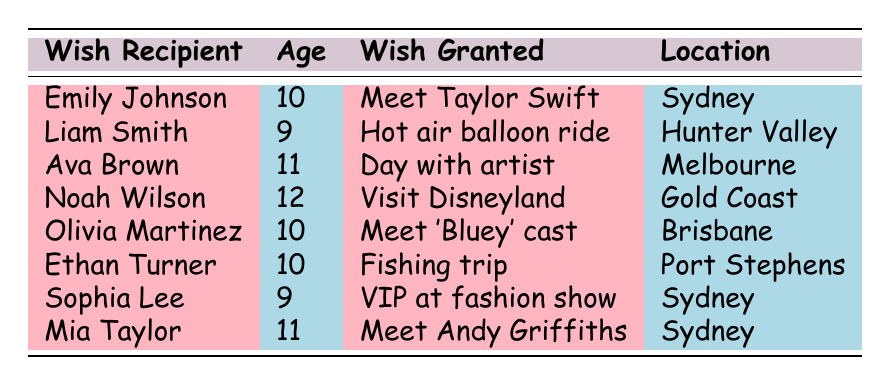What is the wish granted to Emily Johnson? According to the table, Emily Johnson's wish granted was to meet her favorite singer, Taylor Swift.
Answer: Meet Taylor Swift How many wish recipients are 10 years old? The table lists three recipients who are 10 years old: Emily Johnson, Olivia Martinez, and Ethan Turner.
Answer: 3 Which location had the most wishes granted? The table does not list any repeated locations; each location appears only once. Thus, no location has more than one wish granted.
Answer: No location has multiple wishes What type of wish did Liam Smith receive? Referring to the table, Liam Smith received an "Adventure" type wish to go on a hot air balloon ride.
Answer: Adventure Is Mia Taylor's wish granted related to a book or a TV show? The table states that Mia Taylor's wish was to meet her favorite author, Andy Griffiths, which relates to books, not a TV show.
Answer: No How many wishes were granted in Sydney? The table shows that three wishes were granted in Sydney: Emily Johnson, Sophia Lee, and Mia Taylor.
Answer: 3 Which wish recipients are older than 10 years? From the table, the recipients older than 10 years old are Ava Brown (11) and Noah Wilson (12).
Answer: 2 What is the total number of wish recipients listed? The table lists a total of eight wish recipients, counting each entry.
Answer: 8 Which wish granted was the latest in the year? The table shows that the latest wish granted was to Olivia Martinez on August 5, 2023.
Answer: August 5, 2023 Are there more adventure type wishes or experience type wishes granted? By looking at the table, there are three adventure type wishes (Liam Smith, Ethan Turner) and five experience type wishes (Emily Johnson, Ava Brown, Noah Wilson, Olivia Martinez, Sophia Lee, Mia Taylor). This means there are more experience type wishes.
Answer: Experience wishes are more What is the average age of the wish recipients? To find the average age, add the ages (10 + 9 + 11 + 12 + 10 + 10 + 9 + 11 = 82) and divide by the number of recipients (8). So, 82 divided by 8 equals 10.25.
Answer: 10.25 Which two wish recipients' wish was granted closest to each other? By examining the dates granted, the closest dates are for Liam Smith (June 15) and Ava Brown (July 20), which are 35 days apart.
Answer: Liam Smith and Ava Brown 